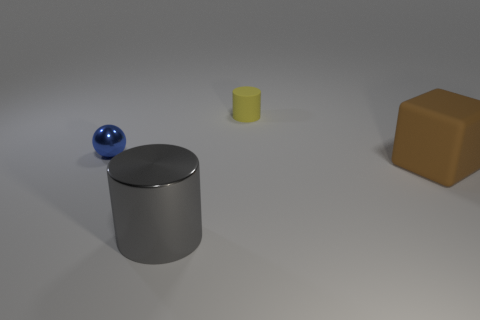How many spheres are the same material as the big gray object?
Make the answer very short. 1. How big is the cylinder that is in front of the rubber thing that is to the left of the cube?
Keep it short and to the point. Large. Do the large gray thing that is left of the tiny yellow object and the tiny thing on the right side of the gray object have the same shape?
Ensure brevity in your answer.  Yes. Are there an equal number of blue metal objects on the right side of the matte cube and big brown matte things?
Keep it short and to the point. No. What is the color of the shiny object that is the same shape as the tiny matte object?
Keep it short and to the point. Gray. Are the large object that is right of the small yellow cylinder and the tiny ball made of the same material?
Your response must be concise. No. How many small things are either cubes or rubber cylinders?
Provide a succinct answer. 1. The brown block is what size?
Give a very brief answer. Large. There is a brown thing; is it the same size as the matte object that is behind the blue metal object?
Provide a succinct answer. No. What number of cyan objects are either small metal cylinders or tiny spheres?
Ensure brevity in your answer.  0. 